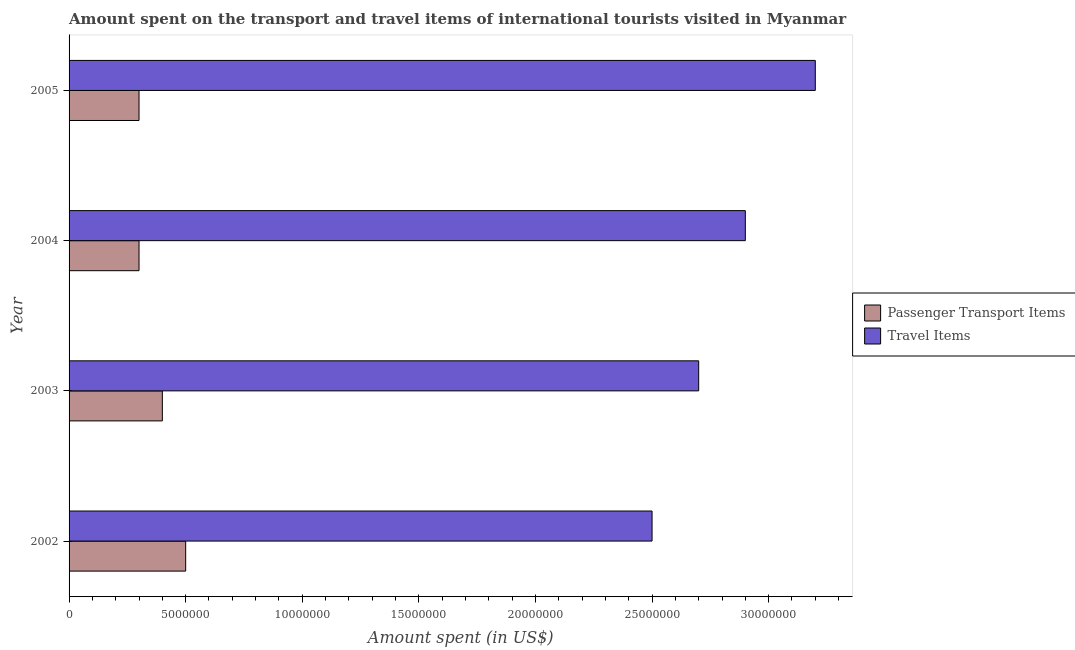How many different coloured bars are there?
Offer a very short reply. 2. What is the amount spent on passenger transport items in 2004?
Your answer should be compact. 3.00e+06. Across all years, what is the maximum amount spent on passenger transport items?
Make the answer very short. 5.00e+06. Across all years, what is the minimum amount spent on passenger transport items?
Your answer should be compact. 3.00e+06. In which year was the amount spent in travel items maximum?
Ensure brevity in your answer.  2005. In which year was the amount spent on passenger transport items minimum?
Your response must be concise. 2004. What is the total amount spent in travel items in the graph?
Make the answer very short. 1.13e+08. What is the difference between the amount spent in travel items in 2002 and that in 2004?
Keep it short and to the point. -4.00e+06. What is the difference between the amount spent in travel items in 2004 and the amount spent on passenger transport items in 2005?
Your answer should be compact. 2.60e+07. What is the average amount spent on passenger transport items per year?
Give a very brief answer. 3.75e+06. In the year 2004, what is the difference between the amount spent on passenger transport items and amount spent in travel items?
Give a very brief answer. -2.60e+07. In how many years, is the amount spent on passenger transport items greater than 4000000 US$?
Your answer should be very brief. 1. What is the ratio of the amount spent in travel items in 2002 to that in 2003?
Offer a terse response. 0.93. What is the difference between the highest and the lowest amount spent on passenger transport items?
Provide a succinct answer. 2.00e+06. In how many years, is the amount spent on passenger transport items greater than the average amount spent on passenger transport items taken over all years?
Your response must be concise. 2. Is the sum of the amount spent in travel items in 2002 and 2005 greater than the maximum amount spent on passenger transport items across all years?
Offer a terse response. Yes. What does the 1st bar from the top in 2002 represents?
Offer a very short reply. Travel Items. What does the 2nd bar from the bottom in 2005 represents?
Your answer should be very brief. Travel Items. Are all the bars in the graph horizontal?
Keep it short and to the point. Yes. How many years are there in the graph?
Offer a very short reply. 4. Does the graph contain any zero values?
Your answer should be compact. No. Does the graph contain grids?
Offer a very short reply. No. Where does the legend appear in the graph?
Make the answer very short. Center right. How are the legend labels stacked?
Provide a succinct answer. Vertical. What is the title of the graph?
Ensure brevity in your answer.  Amount spent on the transport and travel items of international tourists visited in Myanmar. Does "All education staff compensation" appear as one of the legend labels in the graph?
Provide a succinct answer. No. What is the label or title of the X-axis?
Offer a very short reply. Amount spent (in US$). What is the Amount spent (in US$) in Travel Items in 2002?
Your answer should be compact. 2.50e+07. What is the Amount spent (in US$) in Passenger Transport Items in 2003?
Make the answer very short. 4.00e+06. What is the Amount spent (in US$) of Travel Items in 2003?
Offer a very short reply. 2.70e+07. What is the Amount spent (in US$) in Passenger Transport Items in 2004?
Keep it short and to the point. 3.00e+06. What is the Amount spent (in US$) in Travel Items in 2004?
Keep it short and to the point. 2.90e+07. What is the Amount spent (in US$) of Passenger Transport Items in 2005?
Give a very brief answer. 3.00e+06. What is the Amount spent (in US$) of Travel Items in 2005?
Offer a terse response. 3.20e+07. Across all years, what is the maximum Amount spent (in US$) of Travel Items?
Ensure brevity in your answer.  3.20e+07. Across all years, what is the minimum Amount spent (in US$) in Travel Items?
Give a very brief answer. 2.50e+07. What is the total Amount spent (in US$) of Passenger Transport Items in the graph?
Offer a terse response. 1.50e+07. What is the total Amount spent (in US$) of Travel Items in the graph?
Give a very brief answer. 1.13e+08. What is the difference between the Amount spent (in US$) in Passenger Transport Items in 2002 and that in 2003?
Offer a very short reply. 1.00e+06. What is the difference between the Amount spent (in US$) in Travel Items in 2002 and that in 2003?
Ensure brevity in your answer.  -2.00e+06. What is the difference between the Amount spent (in US$) in Passenger Transport Items in 2002 and that in 2004?
Ensure brevity in your answer.  2.00e+06. What is the difference between the Amount spent (in US$) of Passenger Transport Items in 2002 and that in 2005?
Keep it short and to the point. 2.00e+06. What is the difference between the Amount spent (in US$) of Travel Items in 2002 and that in 2005?
Provide a succinct answer. -7.00e+06. What is the difference between the Amount spent (in US$) of Passenger Transport Items in 2003 and that in 2004?
Provide a succinct answer. 1.00e+06. What is the difference between the Amount spent (in US$) in Passenger Transport Items in 2003 and that in 2005?
Your response must be concise. 1.00e+06. What is the difference between the Amount spent (in US$) in Travel Items in 2003 and that in 2005?
Offer a terse response. -5.00e+06. What is the difference between the Amount spent (in US$) in Passenger Transport Items in 2004 and that in 2005?
Make the answer very short. 0. What is the difference between the Amount spent (in US$) of Passenger Transport Items in 2002 and the Amount spent (in US$) of Travel Items in 2003?
Your answer should be very brief. -2.20e+07. What is the difference between the Amount spent (in US$) of Passenger Transport Items in 2002 and the Amount spent (in US$) of Travel Items in 2004?
Your response must be concise. -2.40e+07. What is the difference between the Amount spent (in US$) of Passenger Transport Items in 2002 and the Amount spent (in US$) of Travel Items in 2005?
Provide a short and direct response. -2.70e+07. What is the difference between the Amount spent (in US$) in Passenger Transport Items in 2003 and the Amount spent (in US$) in Travel Items in 2004?
Offer a terse response. -2.50e+07. What is the difference between the Amount spent (in US$) in Passenger Transport Items in 2003 and the Amount spent (in US$) in Travel Items in 2005?
Provide a short and direct response. -2.80e+07. What is the difference between the Amount spent (in US$) in Passenger Transport Items in 2004 and the Amount spent (in US$) in Travel Items in 2005?
Give a very brief answer. -2.90e+07. What is the average Amount spent (in US$) in Passenger Transport Items per year?
Your answer should be compact. 3.75e+06. What is the average Amount spent (in US$) of Travel Items per year?
Offer a terse response. 2.82e+07. In the year 2002, what is the difference between the Amount spent (in US$) of Passenger Transport Items and Amount spent (in US$) of Travel Items?
Offer a very short reply. -2.00e+07. In the year 2003, what is the difference between the Amount spent (in US$) of Passenger Transport Items and Amount spent (in US$) of Travel Items?
Your response must be concise. -2.30e+07. In the year 2004, what is the difference between the Amount spent (in US$) of Passenger Transport Items and Amount spent (in US$) of Travel Items?
Your response must be concise. -2.60e+07. In the year 2005, what is the difference between the Amount spent (in US$) in Passenger Transport Items and Amount spent (in US$) in Travel Items?
Ensure brevity in your answer.  -2.90e+07. What is the ratio of the Amount spent (in US$) of Passenger Transport Items in 2002 to that in 2003?
Your answer should be very brief. 1.25. What is the ratio of the Amount spent (in US$) in Travel Items in 2002 to that in 2003?
Provide a succinct answer. 0.93. What is the ratio of the Amount spent (in US$) in Passenger Transport Items in 2002 to that in 2004?
Provide a succinct answer. 1.67. What is the ratio of the Amount spent (in US$) of Travel Items in 2002 to that in 2004?
Offer a very short reply. 0.86. What is the ratio of the Amount spent (in US$) in Travel Items in 2002 to that in 2005?
Give a very brief answer. 0.78. What is the ratio of the Amount spent (in US$) in Travel Items in 2003 to that in 2004?
Provide a short and direct response. 0.93. What is the ratio of the Amount spent (in US$) of Travel Items in 2003 to that in 2005?
Your answer should be very brief. 0.84. What is the ratio of the Amount spent (in US$) of Travel Items in 2004 to that in 2005?
Your response must be concise. 0.91. What is the difference between the highest and the second highest Amount spent (in US$) of Passenger Transport Items?
Ensure brevity in your answer.  1.00e+06. What is the difference between the highest and the lowest Amount spent (in US$) of Passenger Transport Items?
Keep it short and to the point. 2.00e+06. 